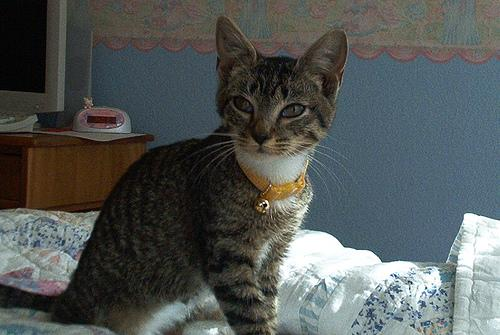Describe the type of cat and its facial features. The cat is a small tabby with grey stripes, blue eyes, white whiskers, and a black end on its nose. Determine the sentiment evoked by the image. The image evokes a calm and cozy sentiment as the cat rests peacefully on the bed. Enumerate the objects found on the wooden desk. On the wooden desk, there are a white paper, a white mechanical keyboard, and a pink Hello Kitty digital clock. Count the number of distinct objects related to the cat and briefly describe each. There are four distinct objects related to the cat: 1) yellow collar, 2) gold bell on the collar, 3) white neck, and 4) black end of the nose. Analyze the interaction between the cat and its surroundings. The cat is resting on a bed with a quilt, and interacting with its collar and bell. Nearby items include a desk with a clock, and a wall painting. Provide a brief description of the wall painting. The wall painting is pink, blue, and white, and has a scalloped edging with a width of 405 and height of 405. Reason about the time period of the objects in the picture. Given the early 2000s desktop computer and the Hello Kitty digital clock, the image likely depicts a scene from the 2000s era. Assess the quality of the image in terms of clarity and detail. The image is of high quality with clear details and sharp representation of objects and their features. Identify the color of the cat's eyes and collar in the picture. The cat has green eyes and is wearing a yellow collar. Provide a short narrative describing the overall scene in the image. A cat with stripes, white whiskers, and yellow collar with a bell rests on a bed covered in a blue, white, and pink comforter, near a brown wooden desk with white paper and a Hello Kitty digital clock on it. Which object is near to the early 2000s desktop computer? White mechanical keyboard What colors are present in the wall painting? Pink, blue, and white Which item is placed on the brown wooden desk? Pink Hello Kitty digital clock Are the cat's eyes blue or green? Green What pattern does the comforter on the bed have? Blue, white, and pink Is the cat sitting on the bed or the desk? On the bed Are the cat's whiskers white or black? White What pattern is on the bed sheet? Blue pattern What is the dominant color of the cat's fur? Black, white, and brown What is the painting on the wall behind the cat? Pink, blue, and white wall painting Describe the cat's unique appearance feature on its nose. The end of the cat's nose is black Describe the position of the gold bell on the cat. On the cat's orange collar What item has a Hello Kitty figure on top of it? Radio clock Identify the type and color of the collar on the cat. Orange collar with bells What are the characteristics of the cat's collar? Yellow with a bell 